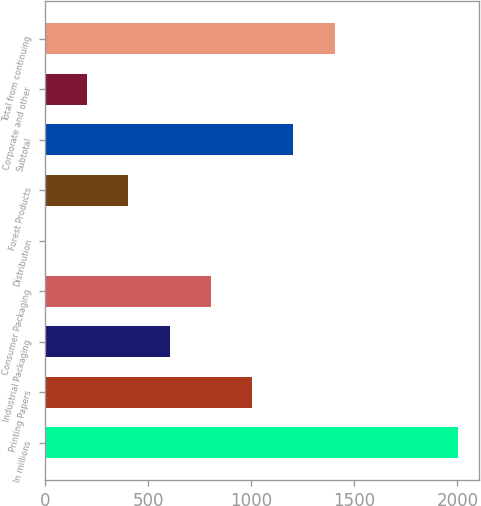Convert chart. <chart><loc_0><loc_0><loc_500><loc_500><bar_chart><fcel>In millions<fcel>Printing Papers<fcel>Industrial Packaging<fcel>Consumer Packaging<fcel>Distribution<fcel>Forest Products<fcel>Subtotal<fcel>Corporate and other<fcel>Total from continuing<nl><fcel>2004<fcel>1004.5<fcel>604.7<fcel>804.6<fcel>5<fcel>404.8<fcel>1204.4<fcel>204.9<fcel>1404.3<nl></chart> 